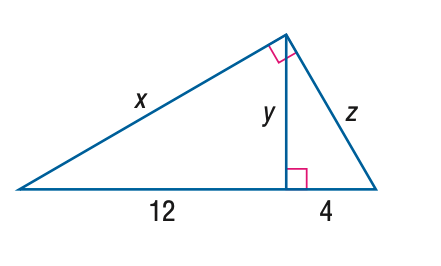Answer the mathemtical geometry problem and directly provide the correct option letter.
Question: Find y.
Choices: A: 4 B: 4 \sqrt { 3 } C: 12 D: 8 \sqrt { 3 } B 